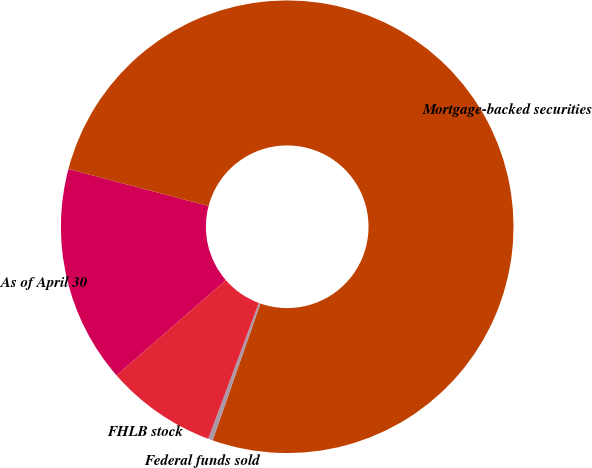Convert chart. <chart><loc_0><loc_0><loc_500><loc_500><pie_chart><fcel>As of April 30<fcel>Mortgage-backed securities<fcel>Federal funds sold<fcel>FHLB stock<nl><fcel>15.51%<fcel>76.24%<fcel>0.33%<fcel>7.92%<nl></chart> 